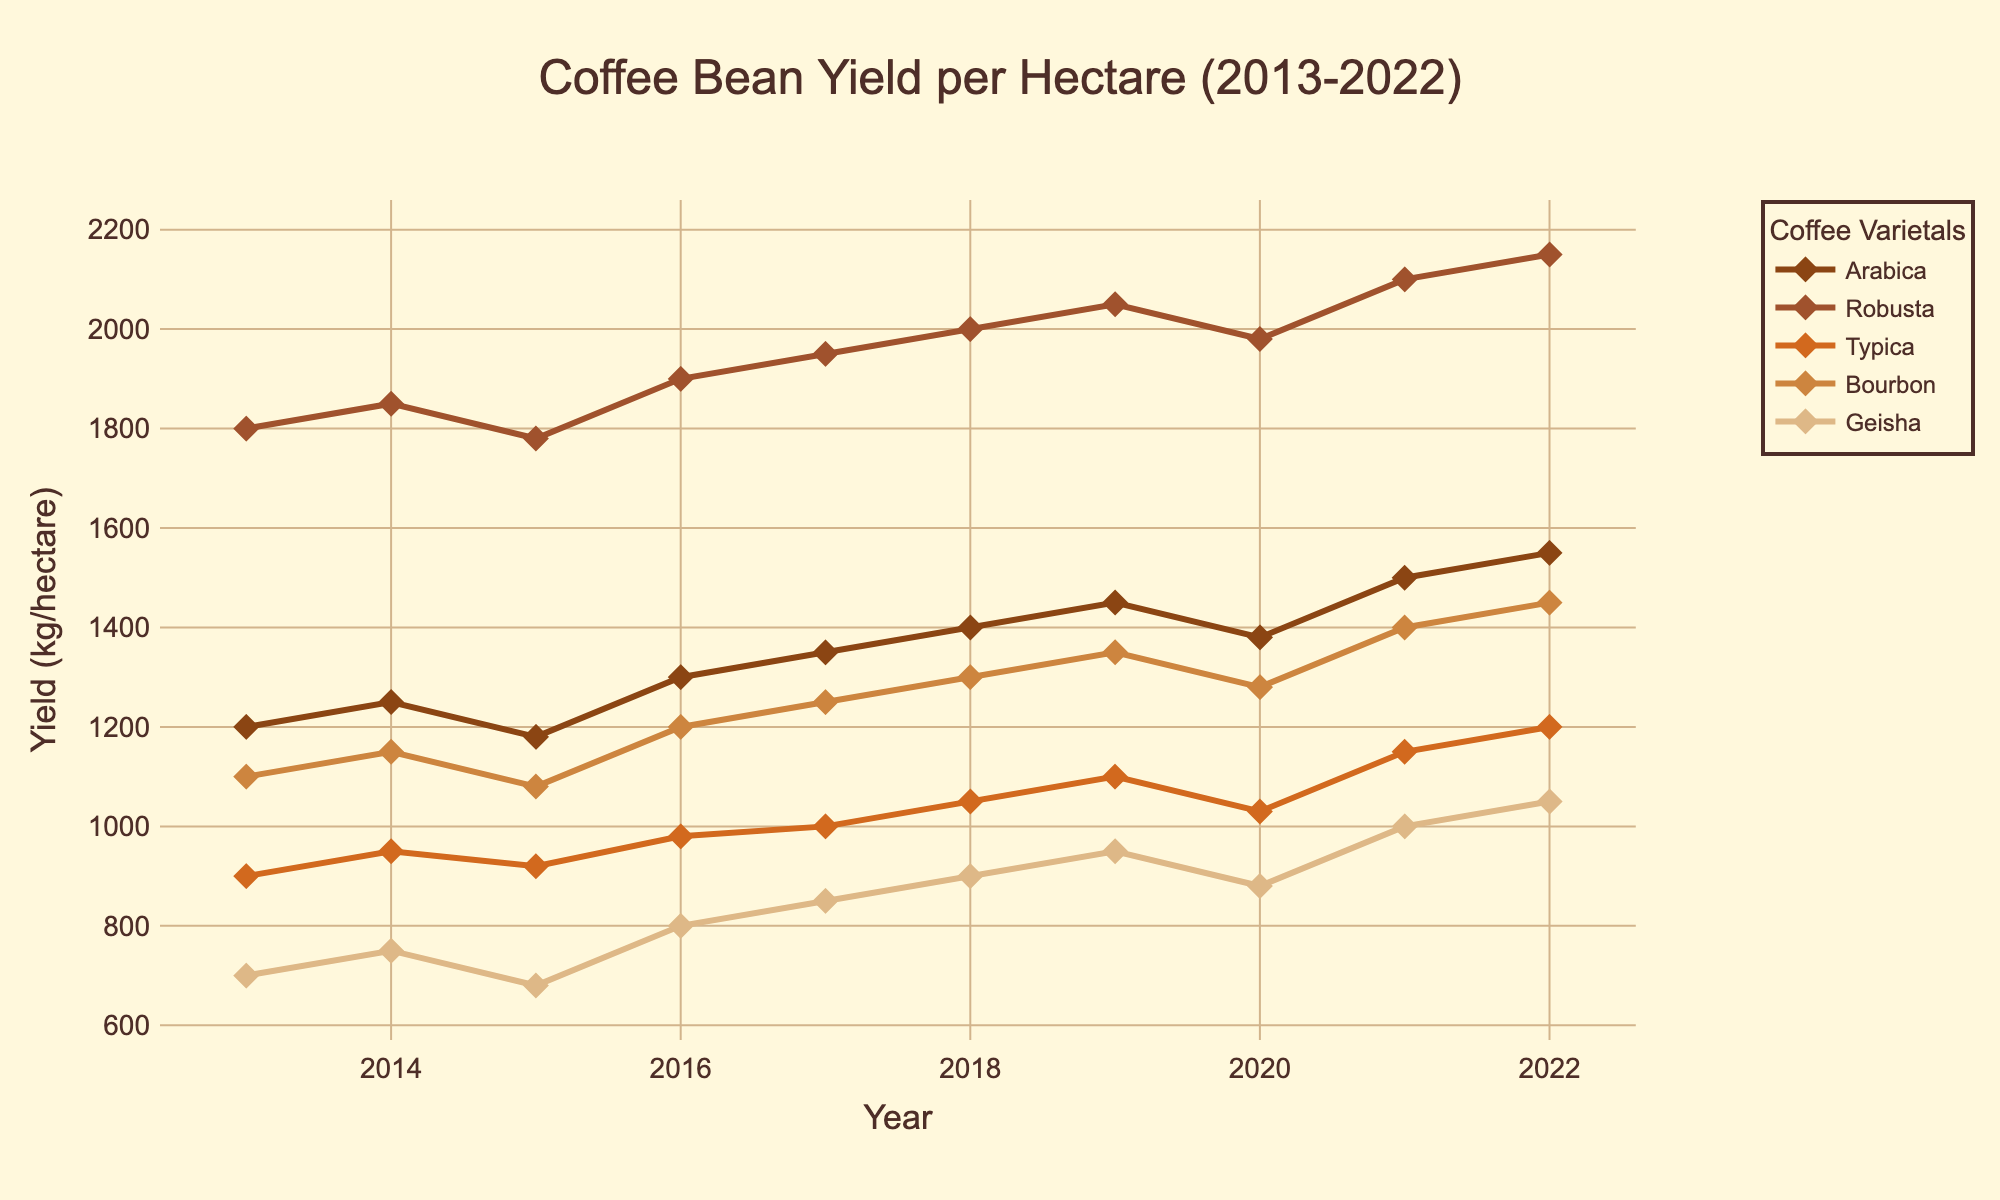What's the overall trend of Arabica yield from 2013 to 2022? Looking at the line for Arabica, it starts from 1200 kg/hectare in 2013 and shows a general upward trend, reaching 1550 kg/hectare in 2022.
Answer: Upward Which varietal had the highest yield in 2017? By comparing the heights of all the lines at the 2017 mark, Robusta, with a yield of 1950 kg/hectare, stands out as the highest.
Answer: Robusta What is the average yield of Typica for the years 2013 to 2022? Sum the Typica yields for each year (900 + 950 + 920 + 980 + 1000 + 1050 + 1100 + 1030 + 1150 + 1200) = 10280. Divide this sum by the number of years, which is 10. 10280 / 10 = 1028.
Answer: 1028 In which year did Bourbon exceed a yield of 1400 kg/hectare for the first time? The Bourbon line crosses the 1400 kg/hectare mark in 2021, which is the first time it exceeds this threshold.
Answer: 2021 Between 2016 and 2017, which varietal had the largest increase in yield? Calculate the increase for each varietal between 2016 and 2017:
- Arabica: 1350 - 1300 = 50
- Robusta: 1950 - 1900 = 50
- Typica: 1000 - 980 = 20
- Bourbon: 1250 - 1200 = 50
- Geisha: 850 - 800 = 50
Since multiple varietals (Arabica, Robusta, Bourbon, Geisha) have the same largest increase (50), list all.
Answer: Arabica, Robusta, Bourbon, Geisha Was there any year when Geisha's yield was higher than Arabica's yield? By comparing the two lines for each year, we see that Geisha's yield is consistently lower than Arabica's across all years.
Answer: No Which two years had the most significant decline in Robusta yield? Check the Robusta yields and find the differences year-over-year:
- 2013 to 2014: 1850 - 1800 = 50
- 2014 to 2015: 1780 - 1850 = -70
- 2015 to 2016: 1900 - 1780 = 120
- 2019 to 2020: 1980 - 2050 = -70
- 2020 to 2021: 2100 - 1980 = 120
So, 2014-2015 and 2019-2020 are the years with the most significant declines.
Answer: 2014-2015 and 2019-2020 Which varietal shows the most consistent annual growth? By visual inspection of the lines' paths, we see that Robusta's line is the smoothest and consistently moving upwards without dramatic dips, indicating the most consistent annual growth.
Answer: Robusta 